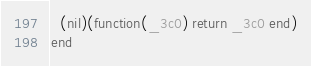Convert code to text. <code><loc_0><loc_0><loc_500><loc_500><_Lua_>  (nil)(function(_3c0) return _3c0 end)
end
</code> 